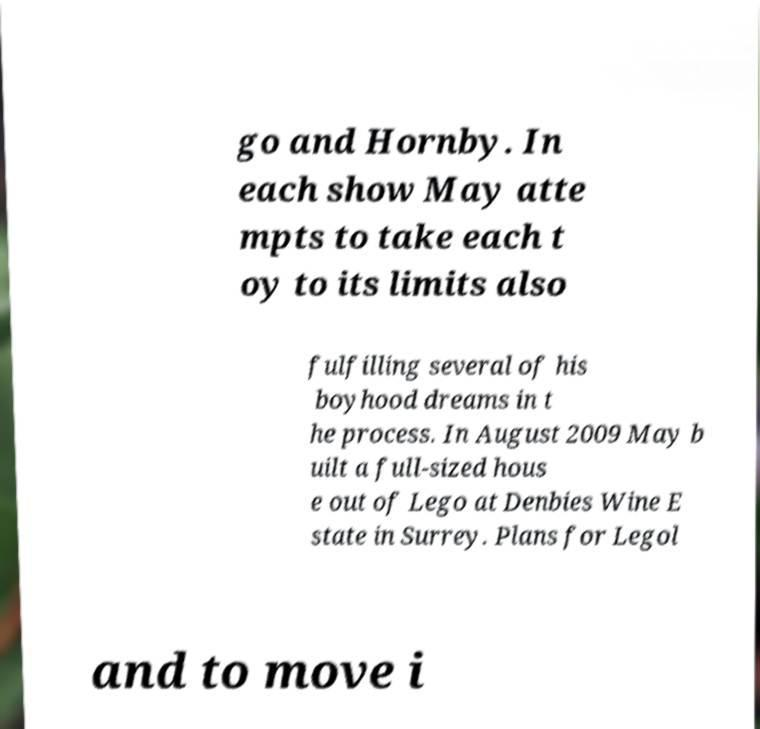Can you read and provide the text displayed in the image?This photo seems to have some interesting text. Can you extract and type it out for me? go and Hornby. In each show May atte mpts to take each t oy to its limits also fulfilling several of his boyhood dreams in t he process. In August 2009 May b uilt a full-sized hous e out of Lego at Denbies Wine E state in Surrey. Plans for Legol and to move i 